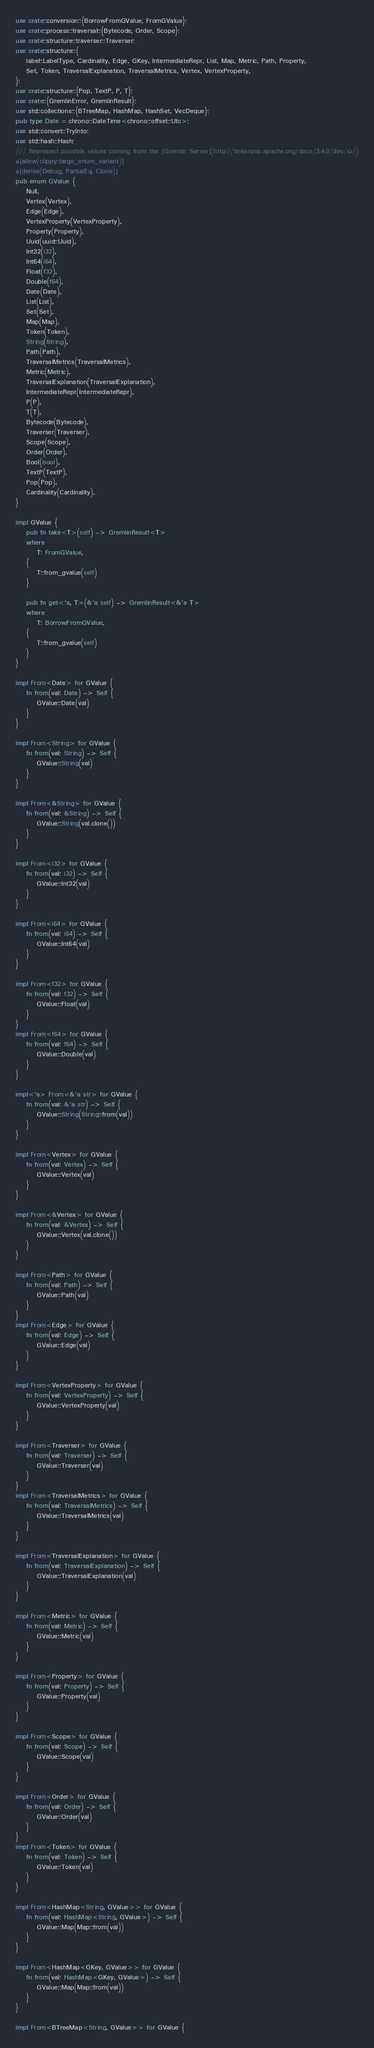<code> <loc_0><loc_0><loc_500><loc_500><_Rust_>use crate::conversion::{BorrowFromGValue, FromGValue};
use crate::process::traversal::{Bytecode, Order, Scope};
use crate::structure::traverser::Traverser;
use crate::structure::{
    label::LabelType, Cardinality, Edge, GKey, IntermediateRepr, List, Map, Metric, Path, Property,
    Set, Token, TraversalExplanation, TraversalMetrics, Vertex, VertexProperty,
};
use crate::structure::{Pop, TextP, P, T};
use crate::{GremlinError, GremlinResult};
use std::collections::{BTreeMap, HashMap, HashSet, VecDeque};
pub type Date = chrono::DateTime<chrono::offset::Utc>;
use std::convert::TryInto;
use std::hash::Hash;
/// Represent possible values coming from the [Gremlin Server](http://tinkerpop.apache.org/docs/3.4.0/dev/io/)
#[allow(clippy::large_enum_variant)]
#[derive(Debug, PartialEq, Clone)]
pub enum GValue {
    Null,
    Vertex(Vertex),
    Edge(Edge),
    VertexProperty(VertexProperty),
    Property(Property),
    Uuid(uuid::Uuid),
    Int32(i32),
    Int64(i64),
    Float(f32),
    Double(f64),
    Date(Date),
    List(List),
    Set(Set),
    Map(Map),
    Token(Token),
    String(String),
    Path(Path),
    TraversalMetrics(TraversalMetrics),
    Metric(Metric),
    TraversalExplanation(TraversalExplanation),
    IntermediateRepr(IntermediateRepr),
    P(P),
    T(T),
    Bytecode(Bytecode),
    Traverser(Traverser),
    Scope(Scope),
    Order(Order),
    Bool(bool),
    TextP(TextP),
    Pop(Pop),
    Cardinality(Cardinality),
}

impl GValue {
    pub fn take<T>(self) -> GremlinResult<T>
    where
        T: FromGValue,
    {
        T::from_gvalue(self)
    }

    pub fn get<'a, T>(&'a self) -> GremlinResult<&'a T>
    where
        T: BorrowFromGValue,
    {
        T::from_gvalue(self)
    }
}

impl From<Date> for GValue {
    fn from(val: Date) -> Self {
        GValue::Date(val)
    }
}

impl From<String> for GValue {
    fn from(val: String) -> Self {
        GValue::String(val)
    }
}

impl From<&String> for GValue {
    fn from(val: &String) -> Self {
        GValue::String(val.clone())
    }
}

impl From<i32> for GValue {
    fn from(val: i32) -> Self {
        GValue::Int32(val)
    }
}

impl From<i64> for GValue {
    fn from(val: i64) -> Self {
        GValue::Int64(val)
    }
}

impl From<f32> for GValue {
    fn from(val: f32) -> Self {
        GValue::Float(val)
    }
}
impl From<f64> for GValue {
    fn from(val: f64) -> Self {
        GValue::Double(val)
    }
}

impl<'a> From<&'a str> for GValue {
    fn from(val: &'a str) -> Self {
        GValue::String(String::from(val))
    }
}

impl From<Vertex> for GValue {
    fn from(val: Vertex) -> Self {
        GValue::Vertex(val)
    }
}

impl From<&Vertex> for GValue {
    fn from(val: &Vertex) -> Self {
        GValue::Vertex(val.clone())
    }
}

impl From<Path> for GValue {
    fn from(val: Path) -> Self {
        GValue::Path(val)
    }
}
impl From<Edge> for GValue {
    fn from(val: Edge) -> Self {
        GValue::Edge(val)
    }
}

impl From<VertexProperty> for GValue {
    fn from(val: VertexProperty) -> Self {
        GValue::VertexProperty(val)
    }
}

impl From<Traverser> for GValue {
    fn from(val: Traverser) -> Self {
        GValue::Traverser(val)
    }
}
impl From<TraversalMetrics> for GValue {
    fn from(val: TraversalMetrics) -> Self {
        GValue::TraversalMetrics(val)
    }
}

impl From<TraversalExplanation> for GValue {
    fn from(val: TraversalExplanation) -> Self {
        GValue::TraversalExplanation(val)
    }
}

impl From<Metric> for GValue {
    fn from(val: Metric) -> Self {
        GValue::Metric(val)
    }
}

impl From<Property> for GValue {
    fn from(val: Property) -> Self {
        GValue::Property(val)
    }
}

impl From<Scope> for GValue {
    fn from(val: Scope) -> Self {
        GValue::Scope(val)
    }
}

impl From<Order> for GValue {
    fn from(val: Order) -> Self {
        GValue::Order(val)
    }
}
impl From<Token> for GValue {
    fn from(val: Token) -> Self {
        GValue::Token(val)
    }
}

impl From<HashMap<String, GValue>> for GValue {
    fn from(val: HashMap<String, GValue>) -> Self {
        GValue::Map(Map::from(val))
    }
}

impl From<HashMap<GKey, GValue>> for GValue {
    fn from(val: HashMap<GKey, GValue>) -> Self {
        GValue::Map(Map::from(val))
    }
}

impl From<BTreeMap<String, GValue>> for GValue {</code> 